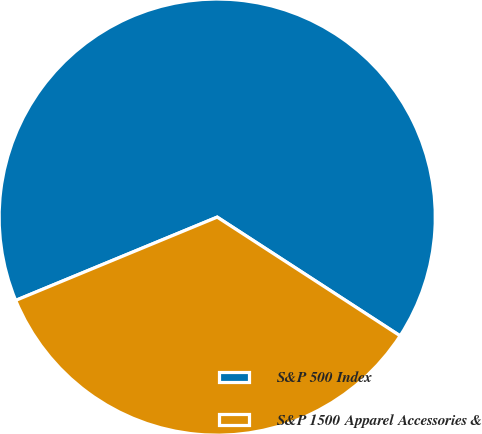Convert chart to OTSL. <chart><loc_0><loc_0><loc_500><loc_500><pie_chart><fcel>S&P 500 Index<fcel>S&P 1500 Apparel Accessories &<nl><fcel>65.4%<fcel>34.6%<nl></chart> 